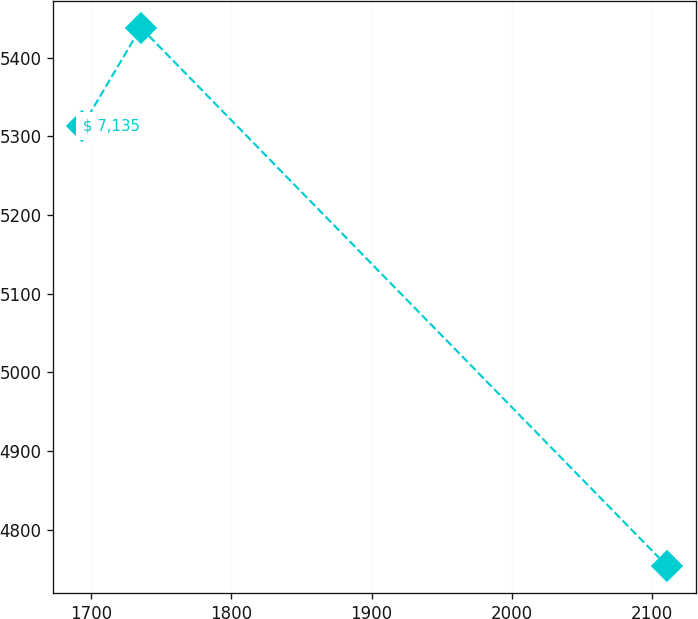Convert chart to OTSL. <chart><loc_0><loc_0><loc_500><loc_500><line_chart><ecel><fcel>$ 7,135<nl><fcel>1693.67<fcel>5312.75<nl><fcel>1735.38<fcel>5438.15<nl><fcel>2110.79<fcel>4753.45<nl></chart> 